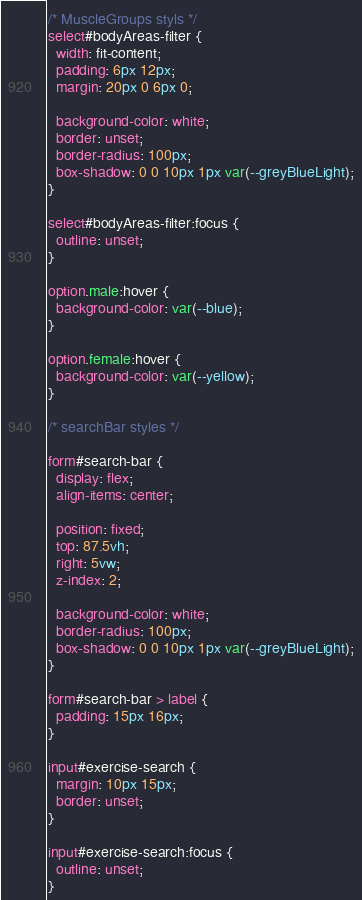<code> <loc_0><loc_0><loc_500><loc_500><_CSS_>/* MuscleGroups styls */
select#bodyAreas-filter {
  width: fit-content;
  padding: 6px 12px;
  margin: 20px 0 6px 0;

  background-color: white;
  border: unset;
  border-radius: 100px;
  box-shadow: 0 0 10px 1px var(--greyBlueLight);
}

select#bodyAreas-filter:focus {
  outline: unset;
}

option.male:hover {
  background-color: var(--blue);
}

option.female:hover {
  background-color: var(--yellow);
}

/* searchBar styles */

form#search-bar {
  display: flex;
  align-items: center;

  position: fixed;
  top: 87.5vh;
  right: 5vw;
  z-index: 2;

  background-color: white;
  border-radius: 100px;
  box-shadow: 0 0 10px 1px var(--greyBlueLight);
}

form#search-bar > label {
  padding: 15px 16px;
}

input#exercise-search {
  margin: 10px 15px;
  border: unset;
}

input#exercise-search:focus {
  outline: unset;
}</code> 